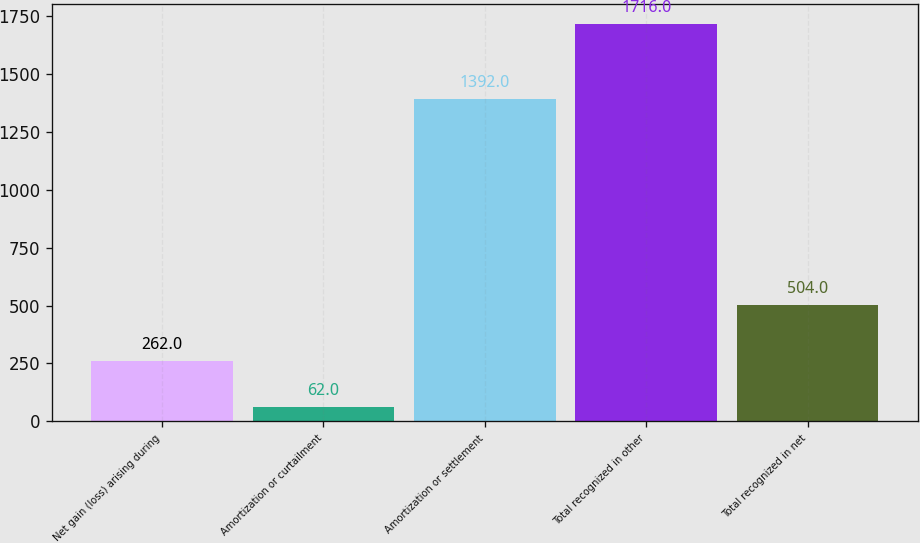Convert chart. <chart><loc_0><loc_0><loc_500><loc_500><bar_chart><fcel>Net gain (loss) arising during<fcel>Amortization or curtailment<fcel>Amortization or settlement<fcel>Total recognized in other<fcel>Total recognized in net<nl><fcel>262<fcel>62<fcel>1392<fcel>1716<fcel>504<nl></chart> 